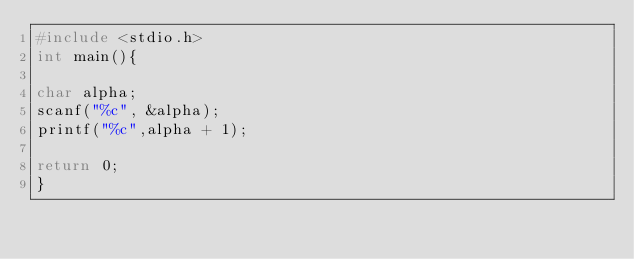Convert code to text. <code><loc_0><loc_0><loc_500><loc_500><_C++_>#include <stdio.h>
int main(){
	
char alpha;
scanf("%c", &alpha);
printf("%c",alpha + 1);

return 0;
}</code> 